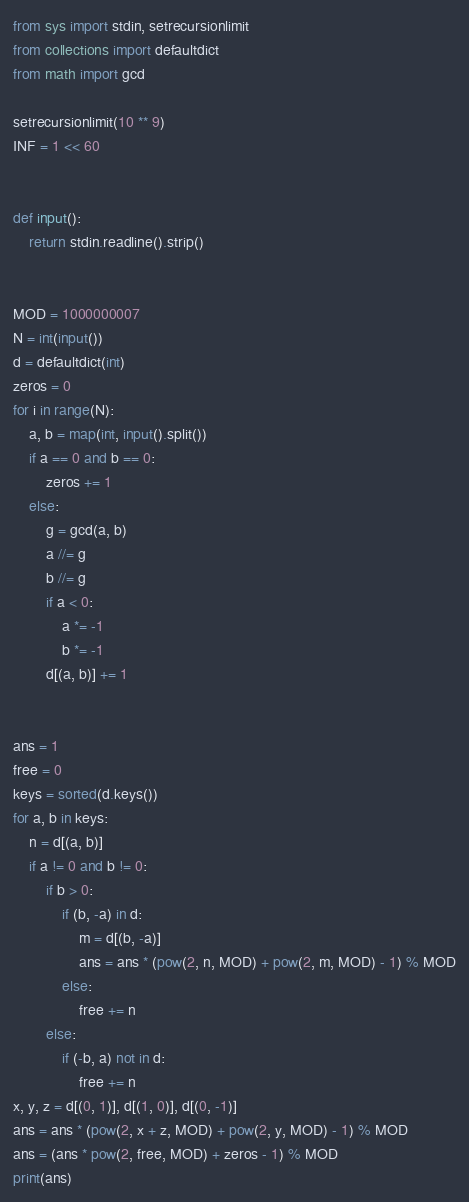<code> <loc_0><loc_0><loc_500><loc_500><_Python_>from sys import stdin, setrecursionlimit
from collections import defaultdict
from math import gcd

setrecursionlimit(10 ** 9)
INF = 1 << 60


def input():
    return stdin.readline().strip()


MOD = 1000000007
N = int(input())
d = defaultdict(int)
zeros = 0
for i in range(N):
    a, b = map(int, input().split())
    if a == 0 and b == 0:
        zeros += 1
    else:
        g = gcd(a, b)
        a //= g
        b //= g
        if a < 0:
            a *= -1
            b *= -1
        d[(a, b)] += 1


ans = 1
free = 0
keys = sorted(d.keys())
for a, b in keys:
    n = d[(a, b)]
    if a != 0 and b != 0:
        if b > 0:
            if (b, -a) in d:
                m = d[(b, -a)]
                ans = ans * (pow(2, n, MOD) + pow(2, m, MOD) - 1) % MOD
            else:
                free += n
        else:
            if (-b, a) not in d:
                free += n
x, y, z = d[(0, 1)], d[(1, 0)], d[(0, -1)]
ans = ans * (pow(2, x + z, MOD) + pow(2, y, MOD) - 1) % MOD
ans = (ans * pow(2, free, MOD) + zeros - 1) % MOD
print(ans)
</code> 